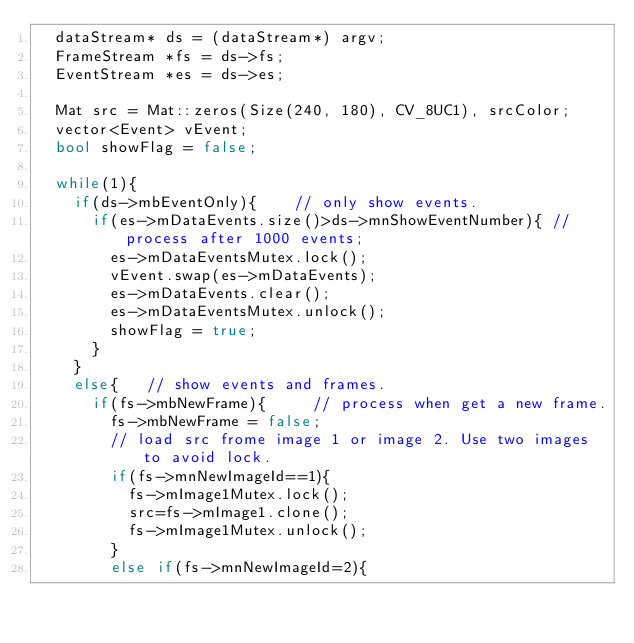<code> <loc_0><loc_0><loc_500><loc_500><_C++_>	dataStream* ds = (dataStream*) argv;
	FrameStream *fs = ds->fs;
	EventStream *es = ds->es;

	Mat src = Mat::zeros(Size(240, 180), CV_8UC1), srcColor;
	vector<Event> vEvent;
	bool showFlag = false;

	while(1){
		if(ds->mbEventOnly){		// only show events.
			if(es->mDataEvents.size()>ds->mnShowEventNumber){	// process after 1000 events;
				es->mDataEventsMutex.lock();
				vEvent.swap(es->mDataEvents);
				es->mDataEvents.clear();
				es->mDataEventsMutex.unlock();
				showFlag = true;
			}
		}
		else{		// show events and frames.
			if(fs->mbNewFrame){			// process when get a new frame.
				fs->mbNewFrame = false;
				// load src frome image 1 or image 2. Use two images to avoid lock.
				if(fs->mnNewImageId==1){
					fs->mImage1Mutex.lock();
					src=fs->mImage1.clone();
					fs->mImage1Mutex.unlock();
				}
				else if(fs->mnNewImageId=2){</code> 